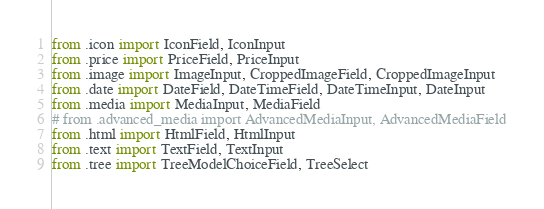Convert code to text. <code><loc_0><loc_0><loc_500><loc_500><_Python_>from .icon import IconField, IconInput
from .price import PriceField, PriceInput
from .image import ImageInput, CroppedImageField, CroppedImageInput
from .date import DateField, DateTimeField, DateTimeInput, DateInput
from .media import MediaInput, MediaField
# from .advanced_media import AdvancedMediaInput, AdvancedMediaField
from .html import HtmlField, HtmlInput
from .text import TextField, TextInput
from .tree import TreeModelChoiceField, TreeSelect
</code> 